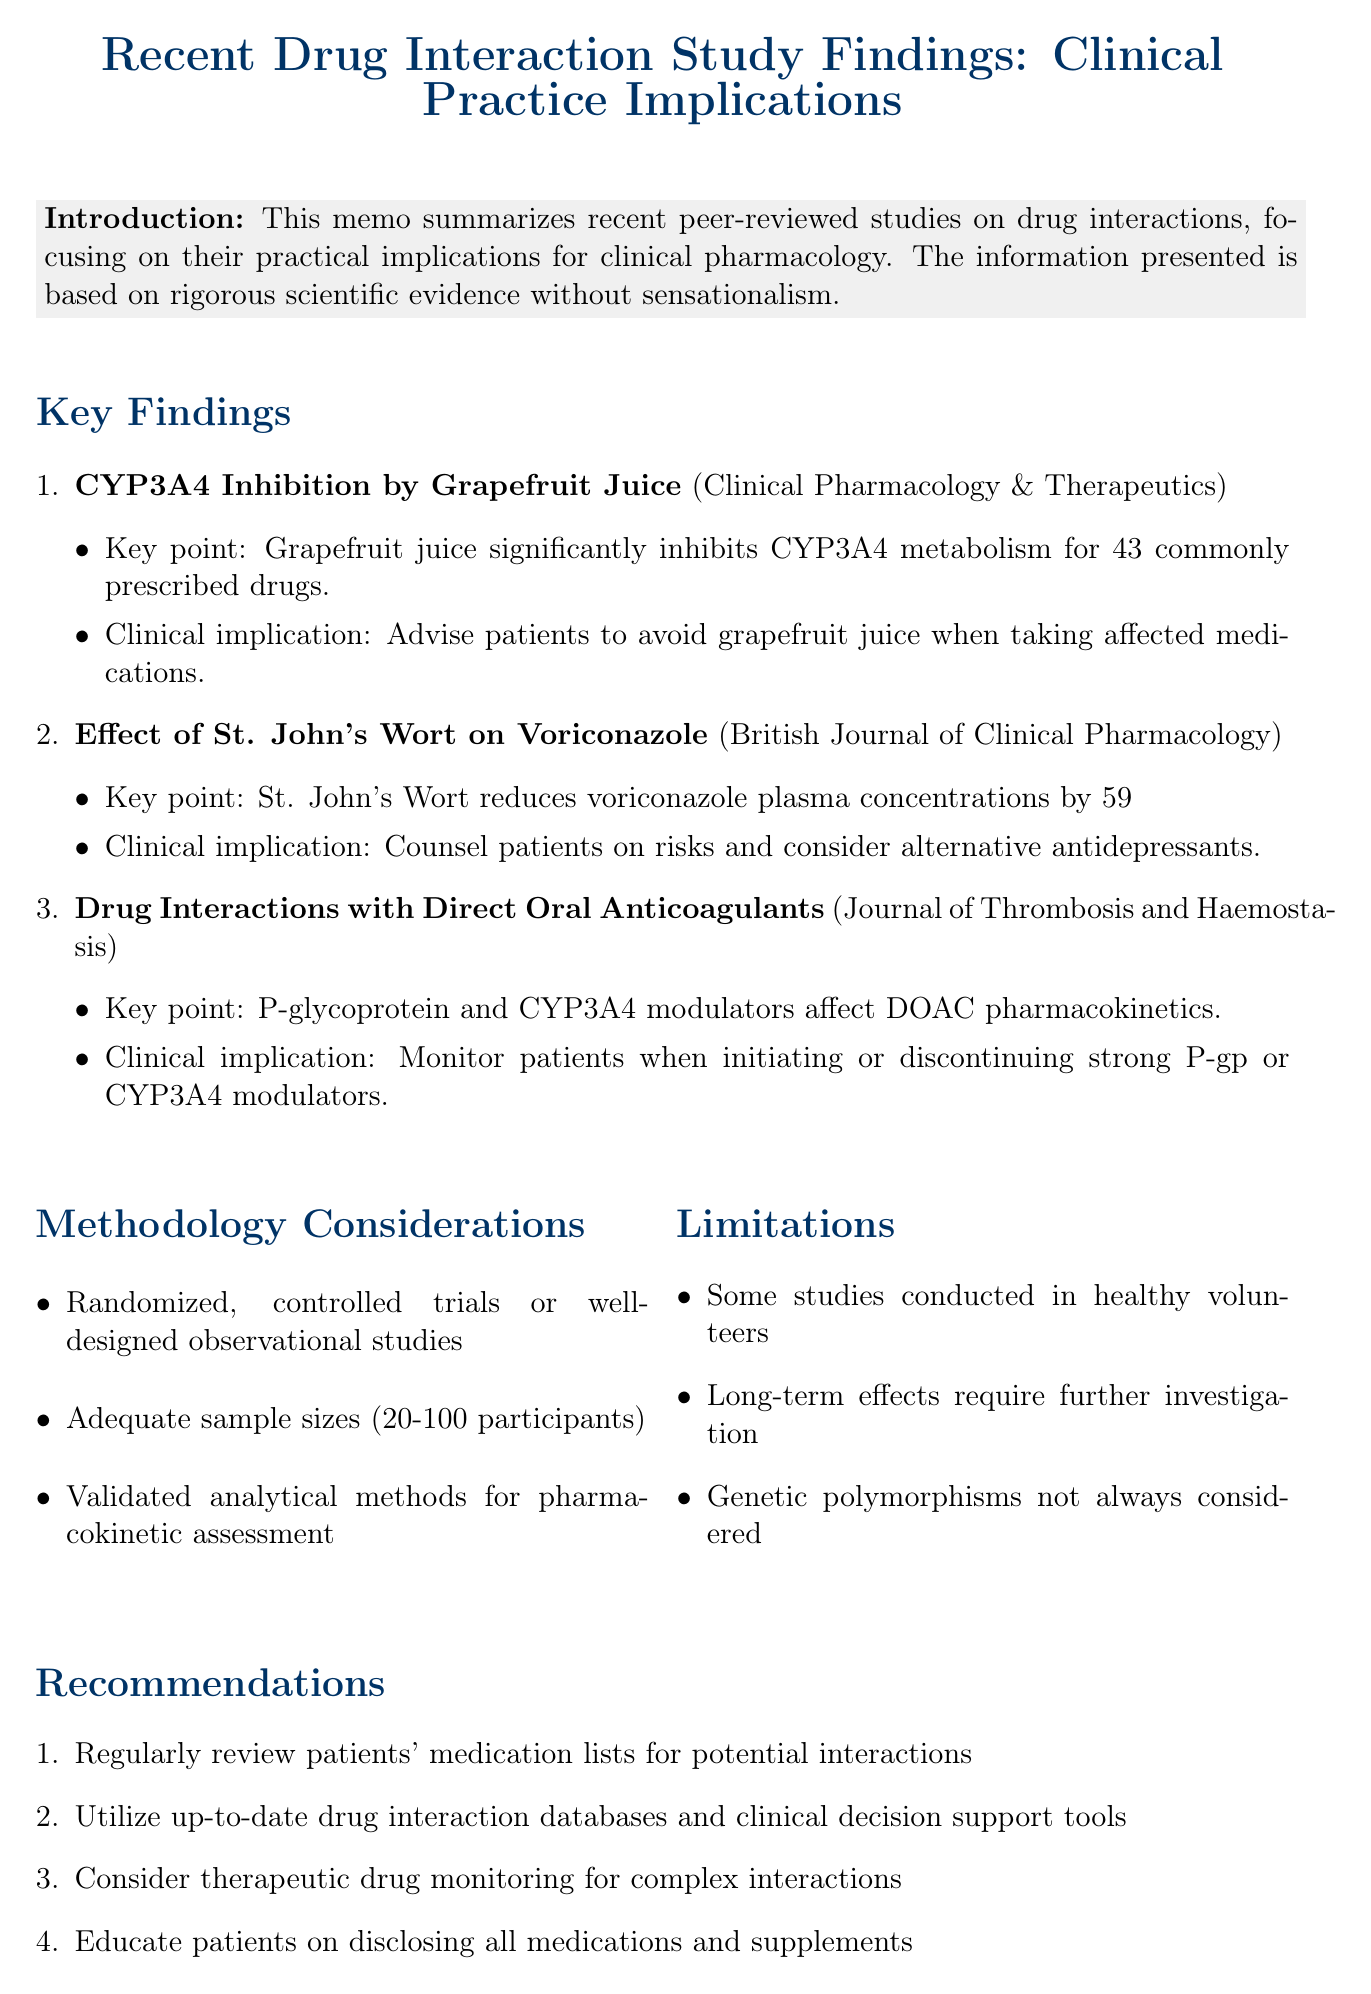what is the title of the memo? The title of the memo is presented at the top of the document, summarizing the contents.
Answer: Recent Drug Interaction Study Findings: Clinical Practice Implications how many drugs are affected by grapefruit juice according to the study? The key finding states that grapefruit juice significantly inhibits CYP3A4 metabolism for 43 commonly prescribed drugs.
Answer: 43 which journal published the study on St. John's Wort? The specific journal where the study on St. John's Wort was published is mentioned next to the study title.
Answer: British Journal of Clinical Pharmacology what percentage does St. John's Wort reduce voriconazole plasma concentrations? The key point regarding voriconazole indicates the extent of the reduction in plasma concentrations.
Answer: 59% what is one of the recommendations for managing drug interactions? The recommendations section lists several strategies for managing drug interactions that can be implemented in clinical practice.
Answer: Regularly review patients' medication lists for potential interactions what are the limitations regarding the studies mentioned? The limitations provide insights into the context and applicability of the studies presented in the document.
Answer: Some studies conducted in healthy volunteers which pharmacokinetic inhibitors should be monitored when using direct oral anticoagulants? The study detail indicates specific types of inhibitors or inducers that affect pharmacokinetics for DOACs.
Answer: P-glycoprotein and CYP3A4 which methodologies were considered in the findings? The methodology considerations outline the type of studies and parameters assessed for validity.
Answer: Randomized, controlled trials or well-designed observational studies 